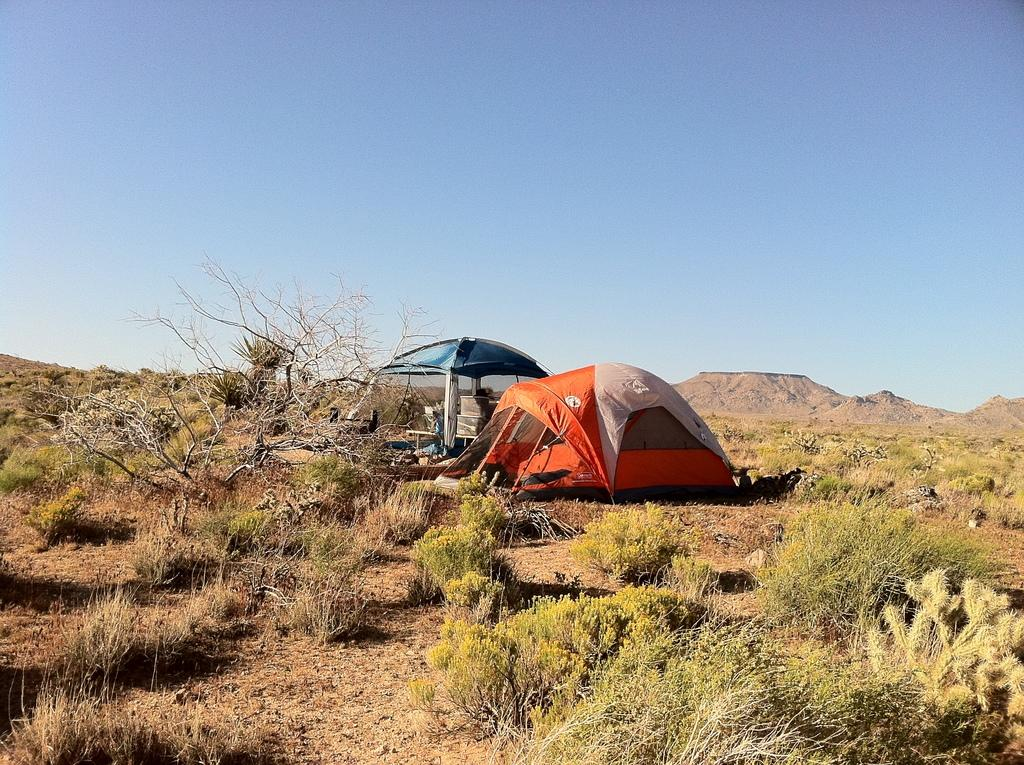What type of vegetation can be seen in the image? There are plants and trees in the image. What structures are present on the ground in the image? There are tents on the ground in the image. What color is the sky in the image? The sky is blue in the image. Can you see any words or pens in the image? There are no words or pens present in the image. Was there an earthquake in the image? There is no indication of an earthquake in the image. 